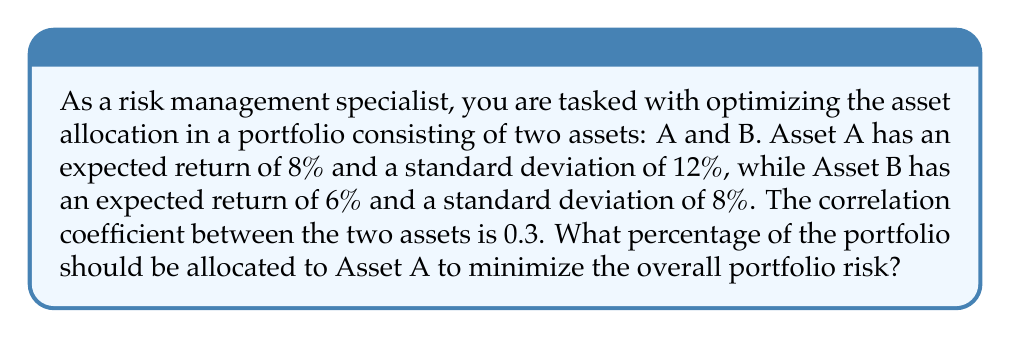Provide a solution to this math problem. To solve this problem, we'll use the portfolio variance formula and minimize it. Let's follow these steps:

1. Define variables:
   $w_A$ = weight of Asset A
   $w_B$ = weight of Asset B (note that $w_B = 1 - w_A$)
   $\sigma_A$ = standard deviation of Asset A = 12%
   $\sigma_B$ = standard deviation of Asset B = 8%
   $\rho_{AB}$ = correlation coefficient between A and B = 0.3

2. The portfolio variance formula is:
   $$\sigma_p^2 = w_A^2\sigma_A^2 + w_B^2\sigma_B^2 + 2w_Aw_B\sigma_A\sigma_B\rho_{AB}$$

3. Substitute $w_B = 1 - w_A$ and the given values:
   $$\sigma_p^2 = w_A^2(0.12)^2 + (1-w_A)^2(0.08)^2 + 2w_A(1-w_A)(0.12)(0.08)(0.3)$$

4. Expand the equation:
   $$\sigma_p^2 = 0.0144w_A^2 + 0.0064 - 0.0128w_A + 0.0064w_A^2 + 0.00576w_A - 0.00576w_A^2$$

5. Simplify:
   $$\sigma_p^2 = 0.015w_A^2 - 0.00704w_A + 0.0064$$

6. To minimize the portfolio variance, we take the derivative with respect to $w_A$ and set it to zero:
   $$\frac{d\sigma_p^2}{dw_A} = 0.03w_A - 0.00704 = 0$$

7. Solve for $w_A$:
   $$0.03w_A = 0.00704$$
   $$w_A = \frac{0.00704}{0.03} = 0.2347$$

8. Verify this is a minimum by checking the second derivative is positive:
   $$\frac{d^2\sigma_p^2}{dw_A^2} = 0.03 > 0$$

Therefore, the portfolio risk is minimized when 23.47% is allocated to Asset A.
Answer: The optimal allocation to minimize portfolio risk is 23.47% in Asset A and 76.53% in Asset B. 